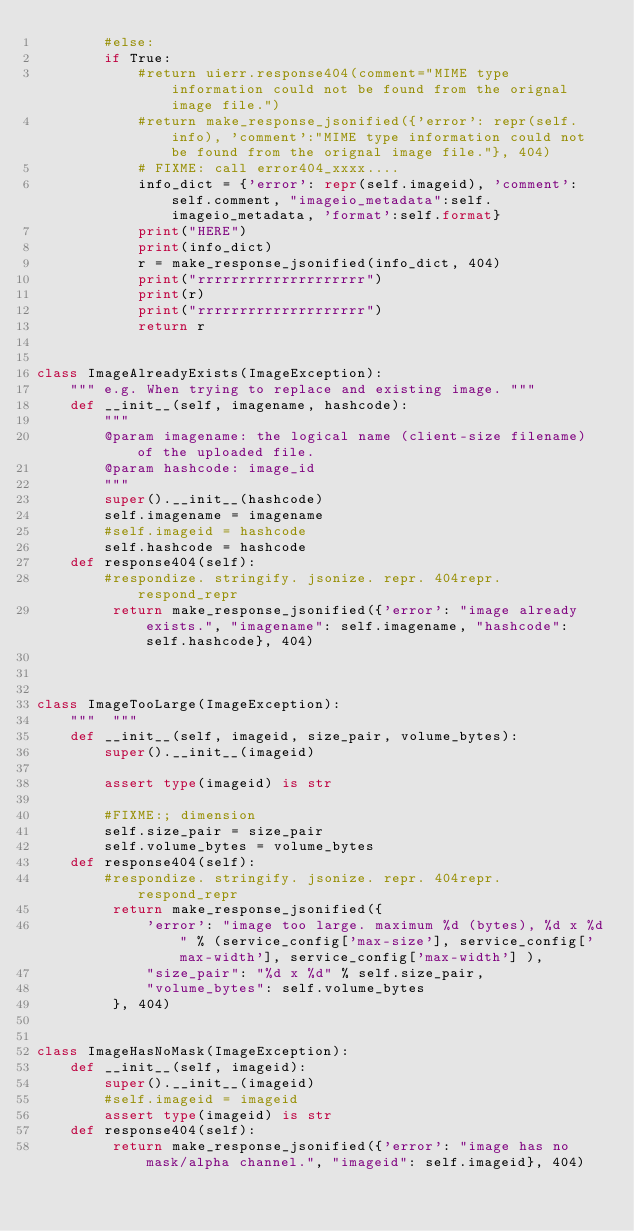<code> <loc_0><loc_0><loc_500><loc_500><_Python_>        #else:
        if True:
            #return uierr.response404(comment="MIME type information could not be found from the orignal image file.")
            #return make_response_jsonified({'error': repr(self.info), 'comment':"MIME type information could not be found from the orignal image file."}, 404)
            # FIXME: call error404_xxxx....
            info_dict = {'error': repr(self.imageid), 'comment':self.comment, "imageio_metadata":self.imageio_metadata, 'format':self.format}
            print("HERE")
            print(info_dict)
            r = make_response_jsonified(info_dict, 404)
            print("rrrrrrrrrrrrrrrrrrrr")
            print(r)
            print("rrrrrrrrrrrrrrrrrrrr")
            return r


class ImageAlreadyExists(ImageException):
    """ e.g. When trying to replace and existing image. """
    def __init__(self, imagename, hashcode):
        """
        @param imagename: the logical name (client-size filename) of the uploaded file.
        @param hashcode: image_id
        """
        super().__init__(hashcode)
        self.imagename = imagename
        #self.imageid = hashcode
        self.hashcode = hashcode
    def response404(self):
        #respondize. stringify. jsonize. repr. 404repr. respond_repr
         return make_response_jsonified({'error': "image already exists.", "imagename": self.imagename, "hashcode": self.hashcode}, 404)



class ImageTooLarge(ImageException):
    """  """
    def __init__(self, imageid, size_pair, volume_bytes):
        super().__init__(imageid)

        assert type(imageid) is str

        #FIXME:; dimension
        self.size_pair = size_pair
        self.volume_bytes = volume_bytes
    def response404(self):
        #respondize. stringify. jsonize. repr. 404repr. respond_repr
         return make_response_jsonified({
             'error': "image too large. maximum %d (bytes), %d x %d" % (service_config['max-size'], service_config['max-width'], service_config['max-width'] ),
             "size_pair": "%d x %d" % self.size_pair,
             "volume_bytes": self.volume_bytes
         }, 404)


class ImageHasNoMask(ImageException):
    def __init__(self, imageid):
        super().__init__(imageid)
        #self.imageid = imageid
        assert type(imageid) is str
    def response404(self):
         return make_response_jsonified({'error': "image has no mask/alpha channel.", "imageid": self.imageid}, 404)
</code> 